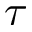<formula> <loc_0><loc_0><loc_500><loc_500>\tau</formula> 